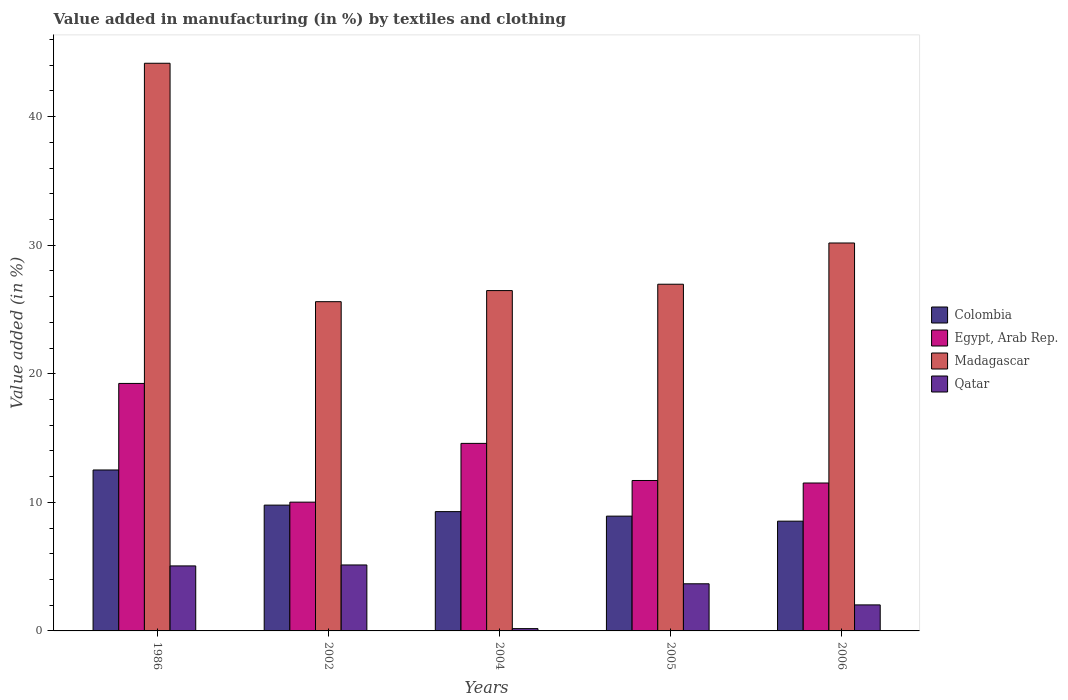How many groups of bars are there?
Provide a succinct answer. 5. Are the number of bars per tick equal to the number of legend labels?
Provide a short and direct response. Yes. Are the number of bars on each tick of the X-axis equal?
Your response must be concise. Yes. How many bars are there on the 1st tick from the left?
Your answer should be compact. 4. How many bars are there on the 5th tick from the right?
Your answer should be compact. 4. What is the label of the 3rd group of bars from the left?
Your answer should be very brief. 2004. In how many cases, is the number of bars for a given year not equal to the number of legend labels?
Your answer should be compact. 0. What is the percentage of value added in manufacturing by textiles and clothing in Colombia in 2002?
Your answer should be very brief. 9.78. Across all years, what is the maximum percentage of value added in manufacturing by textiles and clothing in Egypt, Arab Rep.?
Provide a succinct answer. 19.25. Across all years, what is the minimum percentage of value added in manufacturing by textiles and clothing in Egypt, Arab Rep.?
Give a very brief answer. 10.02. In which year was the percentage of value added in manufacturing by textiles and clothing in Egypt, Arab Rep. minimum?
Offer a very short reply. 2002. What is the total percentage of value added in manufacturing by textiles and clothing in Egypt, Arab Rep. in the graph?
Provide a succinct answer. 67.05. What is the difference between the percentage of value added in manufacturing by textiles and clothing in Egypt, Arab Rep. in 1986 and that in 2006?
Provide a succinct answer. 7.75. What is the difference between the percentage of value added in manufacturing by textiles and clothing in Colombia in 2005 and the percentage of value added in manufacturing by textiles and clothing in Egypt, Arab Rep. in 2006?
Ensure brevity in your answer.  -2.58. What is the average percentage of value added in manufacturing by textiles and clothing in Egypt, Arab Rep. per year?
Offer a very short reply. 13.41. In the year 1986, what is the difference between the percentage of value added in manufacturing by textiles and clothing in Colombia and percentage of value added in manufacturing by textiles and clothing in Madagascar?
Your answer should be compact. -31.63. What is the ratio of the percentage of value added in manufacturing by textiles and clothing in Qatar in 1986 to that in 2002?
Provide a short and direct response. 0.99. What is the difference between the highest and the second highest percentage of value added in manufacturing by textiles and clothing in Qatar?
Your answer should be very brief. 0.07. What is the difference between the highest and the lowest percentage of value added in manufacturing by textiles and clothing in Egypt, Arab Rep.?
Ensure brevity in your answer.  9.23. In how many years, is the percentage of value added in manufacturing by textiles and clothing in Egypt, Arab Rep. greater than the average percentage of value added in manufacturing by textiles and clothing in Egypt, Arab Rep. taken over all years?
Ensure brevity in your answer.  2. Is the sum of the percentage of value added in manufacturing by textiles and clothing in Qatar in 1986 and 2002 greater than the maximum percentage of value added in manufacturing by textiles and clothing in Egypt, Arab Rep. across all years?
Provide a succinct answer. No. What does the 3rd bar from the right in 2004 represents?
Give a very brief answer. Egypt, Arab Rep. How many bars are there?
Make the answer very short. 20. Are all the bars in the graph horizontal?
Your answer should be compact. No. Are the values on the major ticks of Y-axis written in scientific E-notation?
Give a very brief answer. No. Does the graph contain any zero values?
Keep it short and to the point. No. Does the graph contain grids?
Make the answer very short. No. Where does the legend appear in the graph?
Keep it short and to the point. Center right. How many legend labels are there?
Provide a short and direct response. 4. How are the legend labels stacked?
Your answer should be very brief. Vertical. What is the title of the graph?
Ensure brevity in your answer.  Value added in manufacturing (in %) by textiles and clothing. Does "St. Lucia" appear as one of the legend labels in the graph?
Make the answer very short. No. What is the label or title of the X-axis?
Your answer should be very brief. Years. What is the label or title of the Y-axis?
Offer a terse response. Value added (in %). What is the Value added (in %) in Colombia in 1986?
Your answer should be very brief. 12.52. What is the Value added (in %) in Egypt, Arab Rep. in 1986?
Ensure brevity in your answer.  19.25. What is the Value added (in %) of Madagascar in 1986?
Provide a short and direct response. 44.15. What is the Value added (in %) of Qatar in 1986?
Your response must be concise. 5.06. What is the Value added (in %) in Colombia in 2002?
Provide a short and direct response. 9.78. What is the Value added (in %) of Egypt, Arab Rep. in 2002?
Provide a succinct answer. 10.02. What is the Value added (in %) of Madagascar in 2002?
Ensure brevity in your answer.  25.61. What is the Value added (in %) in Qatar in 2002?
Your response must be concise. 5.13. What is the Value added (in %) in Colombia in 2004?
Give a very brief answer. 9.28. What is the Value added (in %) of Egypt, Arab Rep. in 2004?
Make the answer very short. 14.59. What is the Value added (in %) in Madagascar in 2004?
Ensure brevity in your answer.  26.47. What is the Value added (in %) of Qatar in 2004?
Make the answer very short. 0.18. What is the Value added (in %) of Colombia in 2005?
Make the answer very short. 8.93. What is the Value added (in %) of Egypt, Arab Rep. in 2005?
Your response must be concise. 11.7. What is the Value added (in %) in Madagascar in 2005?
Keep it short and to the point. 26.96. What is the Value added (in %) in Qatar in 2005?
Offer a terse response. 3.67. What is the Value added (in %) of Colombia in 2006?
Provide a short and direct response. 8.54. What is the Value added (in %) in Egypt, Arab Rep. in 2006?
Your answer should be very brief. 11.5. What is the Value added (in %) in Madagascar in 2006?
Make the answer very short. 30.17. What is the Value added (in %) of Qatar in 2006?
Provide a succinct answer. 2.02. Across all years, what is the maximum Value added (in %) of Colombia?
Offer a very short reply. 12.52. Across all years, what is the maximum Value added (in %) of Egypt, Arab Rep.?
Make the answer very short. 19.25. Across all years, what is the maximum Value added (in %) of Madagascar?
Ensure brevity in your answer.  44.15. Across all years, what is the maximum Value added (in %) of Qatar?
Your answer should be compact. 5.13. Across all years, what is the minimum Value added (in %) in Colombia?
Your response must be concise. 8.54. Across all years, what is the minimum Value added (in %) of Egypt, Arab Rep.?
Keep it short and to the point. 10.02. Across all years, what is the minimum Value added (in %) in Madagascar?
Ensure brevity in your answer.  25.61. Across all years, what is the minimum Value added (in %) in Qatar?
Ensure brevity in your answer.  0.18. What is the total Value added (in %) of Colombia in the graph?
Provide a succinct answer. 49.04. What is the total Value added (in %) in Egypt, Arab Rep. in the graph?
Provide a succinct answer. 67.05. What is the total Value added (in %) of Madagascar in the graph?
Keep it short and to the point. 153.36. What is the total Value added (in %) in Qatar in the graph?
Your answer should be very brief. 16.05. What is the difference between the Value added (in %) in Colombia in 1986 and that in 2002?
Make the answer very short. 2.73. What is the difference between the Value added (in %) in Egypt, Arab Rep. in 1986 and that in 2002?
Your answer should be compact. 9.23. What is the difference between the Value added (in %) in Madagascar in 1986 and that in 2002?
Provide a succinct answer. 18.54. What is the difference between the Value added (in %) in Qatar in 1986 and that in 2002?
Give a very brief answer. -0.07. What is the difference between the Value added (in %) of Colombia in 1986 and that in 2004?
Your answer should be compact. 3.24. What is the difference between the Value added (in %) in Egypt, Arab Rep. in 1986 and that in 2004?
Provide a short and direct response. 4.66. What is the difference between the Value added (in %) in Madagascar in 1986 and that in 2004?
Provide a succinct answer. 17.68. What is the difference between the Value added (in %) in Qatar in 1986 and that in 2004?
Make the answer very short. 4.88. What is the difference between the Value added (in %) in Colombia in 1986 and that in 2005?
Offer a terse response. 3.59. What is the difference between the Value added (in %) of Egypt, Arab Rep. in 1986 and that in 2005?
Offer a terse response. 7.55. What is the difference between the Value added (in %) in Madagascar in 1986 and that in 2005?
Your response must be concise. 17.19. What is the difference between the Value added (in %) in Qatar in 1986 and that in 2005?
Make the answer very short. 1.39. What is the difference between the Value added (in %) of Colombia in 1986 and that in 2006?
Ensure brevity in your answer.  3.98. What is the difference between the Value added (in %) of Egypt, Arab Rep. in 1986 and that in 2006?
Ensure brevity in your answer.  7.75. What is the difference between the Value added (in %) in Madagascar in 1986 and that in 2006?
Your answer should be very brief. 13.98. What is the difference between the Value added (in %) in Qatar in 1986 and that in 2006?
Offer a terse response. 3.03. What is the difference between the Value added (in %) of Colombia in 2002 and that in 2004?
Offer a very short reply. 0.5. What is the difference between the Value added (in %) of Egypt, Arab Rep. in 2002 and that in 2004?
Provide a succinct answer. -4.57. What is the difference between the Value added (in %) in Madagascar in 2002 and that in 2004?
Your answer should be compact. -0.86. What is the difference between the Value added (in %) of Qatar in 2002 and that in 2004?
Give a very brief answer. 4.95. What is the difference between the Value added (in %) in Colombia in 2002 and that in 2005?
Your response must be concise. 0.86. What is the difference between the Value added (in %) in Egypt, Arab Rep. in 2002 and that in 2005?
Make the answer very short. -1.68. What is the difference between the Value added (in %) in Madagascar in 2002 and that in 2005?
Your answer should be very brief. -1.36. What is the difference between the Value added (in %) in Qatar in 2002 and that in 2005?
Offer a terse response. 1.47. What is the difference between the Value added (in %) in Colombia in 2002 and that in 2006?
Provide a short and direct response. 1.25. What is the difference between the Value added (in %) in Egypt, Arab Rep. in 2002 and that in 2006?
Your answer should be very brief. -1.49. What is the difference between the Value added (in %) of Madagascar in 2002 and that in 2006?
Provide a succinct answer. -4.57. What is the difference between the Value added (in %) of Qatar in 2002 and that in 2006?
Your response must be concise. 3.11. What is the difference between the Value added (in %) in Colombia in 2004 and that in 2005?
Make the answer very short. 0.35. What is the difference between the Value added (in %) in Egypt, Arab Rep. in 2004 and that in 2005?
Your response must be concise. 2.89. What is the difference between the Value added (in %) in Madagascar in 2004 and that in 2005?
Your response must be concise. -0.49. What is the difference between the Value added (in %) in Qatar in 2004 and that in 2005?
Offer a terse response. -3.49. What is the difference between the Value added (in %) in Colombia in 2004 and that in 2006?
Keep it short and to the point. 0.74. What is the difference between the Value added (in %) in Egypt, Arab Rep. in 2004 and that in 2006?
Keep it short and to the point. 3.08. What is the difference between the Value added (in %) of Madagascar in 2004 and that in 2006?
Ensure brevity in your answer.  -3.7. What is the difference between the Value added (in %) of Qatar in 2004 and that in 2006?
Keep it short and to the point. -1.85. What is the difference between the Value added (in %) in Colombia in 2005 and that in 2006?
Offer a terse response. 0.39. What is the difference between the Value added (in %) of Egypt, Arab Rep. in 2005 and that in 2006?
Your response must be concise. 0.2. What is the difference between the Value added (in %) in Madagascar in 2005 and that in 2006?
Offer a very short reply. -3.21. What is the difference between the Value added (in %) in Qatar in 2005 and that in 2006?
Your response must be concise. 1.64. What is the difference between the Value added (in %) of Colombia in 1986 and the Value added (in %) of Egypt, Arab Rep. in 2002?
Provide a short and direct response. 2.5. What is the difference between the Value added (in %) in Colombia in 1986 and the Value added (in %) in Madagascar in 2002?
Offer a terse response. -13.09. What is the difference between the Value added (in %) of Colombia in 1986 and the Value added (in %) of Qatar in 2002?
Make the answer very short. 7.39. What is the difference between the Value added (in %) of Egypt, Arab Rep. in 1986 and the Value added (in %) of Madagascar in 2002?
Make the answer very short. -6.36. What is the difference between the Value added (in %) of Egypt, Arab Rep. in 1986 and the Value added (in %) of Qatar in 2002?
Ensure brevity in your answer.  14.12. What is the difference between the Value added (in %) of Madagascar in 1986 and the Value added (in %) of Qatar in 2002?
Offer a terse response. 39.02. What is the difference between the Value added (in %) in Colombia in 1986 and the Value added (in %) in Egypt, Arab Rep. in 2004?
Make the answer very short. -2.07. What is the difference between the Value added (in %) of Colombia in 1986 and the Value added (in %) of Madagascar in 2004?
Provide a short and direct response. -13.95. What is the difference between the Value added (in %) in Colombia in 1986 and the Value added (in %) in Qatar in 2004?
Keep it short and to the point. 12.34. What is the difference between the Value added (in %) of Egypt, Arab Rep. in 1986 and the Value added (in %) of Madagascar in 2004?
Offer a terse response. -7.22. What is the difference between the Value added (in %) of Egypt, Arab Rep. in 1986 and the Value added (in %) of Qatar in 2004?
Your response must be concise. 19.07. What is the difference between the Value added (in %) in Madagascar in 1986 and the Value added (in %) in Qatar in 2004?
Your answer should be very brief. 43.97. What is the difference between the Value added (in %) of Colombia in 1986 and the Value added (in %) of Egypt, Arab Rep. in 2005?
Keep it short and to the point. 0.82. What is the difference between the Value added (in %) of Colombia in 1986 and the Value added (in %) of Madagascar in 2005?
Provide a succinct answer. -14.45. What is the difference between the Value added (in %) in Colombia in 1986 and the Value added (in %) in Qatar in 2005?
Your answer should be very brief. 8.85. What is the difference between the Value added (in %) in Egypt, Arab Rep. in 1986 and the Value added (in %) in Madagascar in 2005?
Your answer should be very brief. -7.71. What is the difference between the Value added (in %) of Egypt, Arab Rep. in 1986 and the Value added (in %) of Qatar in 2005?
Provide a short and direct response. 15.58. What is the difference between the Value added (in %) in Madagascar in 1986 and the Value added (in %) in Qatar in 2005?
Ensure brevity in your answer.  40.48. What is the difference between the Value added (in %) in Colombia in 1986 and the Value added (in %) in Egypt, Arab Rep. in 2006?
Offer a terse response. 1.01. What is the difference between the Value added (in %) in Colombia in 1986 and the Value added (in %) in Madagascar in 2006?
Provide a short and direct response. -17.65. What is the difference between the Value added (in %) of Colombia in 1986 and the Value added (in %) of Qatar in 2006?
Your answer should be compact. 10.49. What is the difference between the Value added (in %) in Egypt, Arab Rep. in 1986 and the Value added (in %) in Madagascar in 2006?
Your answer should be compact. -10.92. What is the difference between the Value added (in %) of Egypt, Arab Rep. in 1986 and the Value added (in %) of Qatar in 2006?
Offer a very short reply. 17.22. What is the difference between the Value added (in %) of Madagascar in 1986 and the Value added (in %) of Qatar in 2006?
Make the answer very short. 42.12. What is the difference between the Value added (in %) in Colombia in 2002 and the Value added (in %) in Egypt, Arab Rep. in 2004?
Offer a terse response. -4.8. What is the difference between the Value added (in %) of Colombia in 2002 and the Value added (in %) of Madagascar in 2004?
Your response must be concise. -16.69. What is the difference between the Value added (in %) in Colombia in 2002 and the Value added (in %) in Qatar in 2004?
Make the answer very short. 9.61. What is the difference between the Value added (in %) in Egypt, Arab Rep. in 2002 and the Value added (in %) in Madagascar in 2004?
Your answer should be compact. -16.45. What is the difference between the Value added (in %) of Egypt, Arab Rep. in 2002 and the Value added (in %) of Qatar in 2004?
Keep it short and to the point. 9.84. What is the difference between the Value added (in %) in Madagascar in 2002 and the Value added (in %) in Qatar in 2004?
Offer a terse response. 25.43. What is the difference between the Value added (in %) in Colombia in 2002 and the Value added (in %) in Egypt, Arab Rep. in 2005?
Give a very brief answer. -1.92. What is the difference between the Value added (in %) in Colombia in 2002 and the Value added (in %) in Madagascar in 2005?
Your answer should be compact. -17.18. What is the difference between the Value added (in %) in Colombia in 2002 and the Value added (in %) in Qatar in 2005?
Your response must be concise. 6.12. What is the difference between the Value added (in %) in Egypt, Arab Rep. in 2002 and the Value added (in %) in Madagascar in 2005?
Give a very brief answer. -16.95. What is the difference between the Value added (in %) of Egypt, Arab Rep. in 2002 and the Value added (in %) of Qatar in 2005?
Provide a short and direct response. 6.35. What is the difference between the Value added (in %) in Madagascar in 2002 and the Value added (in %) in Qatar in 2005?
Provide a succinct answer. 21.94. What is the difference between the Value added (in %) in Colombia in 2002 and the Value added (in %) in Egypt, Arab Rep. in 2006?
Your answer should be compact. -1.72. What is the difference between the Value added (in %) in Colombia in 2002 and the Value added (in %) in Madagascar in 2006?
Offer a very short reply. -20.39. What is the difference between the Value added (in %) in Colombia in 2002 and the Value added (in %) in Qatar in 2006?
Make the answer very short. 7.76. What is the difference between the Value added (in %) in Egypt, Arab Rep. in 2002 and the Value added (in %) in Madagascar in 2006?
Keep it short and to the point. -20.16. What is the difference between the Value added (in %) in Egypt, Arab Rep. in 2002 and the Value added (in %) in Qatar in 2006?
Your answer should be very brief. 7.99. What is the difference between the Value added (in %) in Madagascar in 2002 and the Value added (in %) in Qatar in 2006?
Keep it short and to the point. 23.58. What is the difference between the Value added (in %) of Colombia in 2004 and the Value added (in %) of Egypt, Arab Rep. in 2005?
Your answer should be compact. -2.42. What is the difference between the Value added (in %) of Colombia in 2004 and the Value added (in %) of Madagascar in 2005?
Give a very brief answer. -17.68. What is the difference between the Value added (in %) in Colombia in 2004 and the Value added (in %) in Qatar in 2005?
Provide a short and direct response. 5.61. What is the difference between the Value added (in %) in Egypt, Arab Rep. in 2004 and the Value added (in %) in Madagascar in 2005?
Your answer should be compact. -12.38. What is the difference between the Value added (in %) of Egypt, Arab Rep. in 2004 and the Value added (in %) of Qatar in 2005?
Make the answer very short. 10.92. What is the difference between the Value added (in %) in Madagascar in 2004 and the Value added (in %) in Qatar in 2005?
Give a very brief answer. 22.8. What is the difference between the Value added (in %) in Colombia in 2004 and the Value added (in %) in Egypt, Arab Rep. in 2006?
Keep it short and to the point. -2.22. What is the difference between the Value added (in %) in Colombia in 2004 and the Value added (in %) in Madagascar in 2006?
Give a very brief answer. -20.89. What is the difference between the Value added (in %) in Colombia in 2004 and the Value added (in %) in Qatar in 2006?
Provide a short and direct response. 7.26. What is the difference between the Value added (in %) of Egypt, Arab Rep. in 2004 and the Value added (in %) of Madagascar in 2006?
Offer a terse response. -15.59. What is the difference between the Value added (in %) of Egypt, Arab Rep. in 2004 and the Value added (in %) of Qatar in 2006?
Offer a very short reply. 12.56. What is the difference between the Value added (in %) of Madagascar in 2004 and the Value added (in %) of Qatar in 2006?
Give a very brief answer. 24.45. What is the difference between the Value added (in %) in Colombia in 2005 and the Value added (in %) in Egypt, Arab Rep. in 2006?
Your answer should be very brief. -2.58. What is the difference between the Value added (in %) of Colombia in 2005 and the Value added (in %) of Madagascar in 2006?
Your response must be concise. -21.24. What is the difference between the Value added (in %) in Colombia in 2005 and the Value added (in %) in Qatar in 2006?
Ensure brevity in your answer.  6.9. What is the difference between the Value added (in %) in Egypt, Arab Rep. in 2005 and the Value added (in %) in Madagascar in 2006?
Your answer should be very brief. -18.47. What is the difference between the Value added (in %) in Egypt, Arab Rep. in 2005 and the Value added (in %) in Qatar in 2006?
Your response must be concise. 9.68. What is the difference between the Value added (in %) of Madagascar in 2005 and the Value added (in %) of Qatar in 2006?
Keep it short and to the point. 24.94. What is the average Value added (in %) in Colombia per year?
Provide a short and direct response. 9.81. What is the average Value added (in %) of Egypt, Arab Rep. per year?
Keep it short and to the point. 13.41. What is the average Value added (in %) in Madagascar per year?
Your answer should be very brief. 30.67. What is the average Value added (in %) of Qatar per year?
Provide a succinct answer. 3.21. In the year 1986, what is the difference between the Value added (in %) of Colombia and Value added (in %) of Egypt, Arab Rep.?
Your answer should be compact. -6.73. In the year 1986, what is the difference between the Value added (in %) in Colombia and Value added (in %) in Madagascar?
Provide a short and direct response. -31.63. In the year 1986, what is the difference between the Value added (in %) in Colombia and Value added (in %) in Qatar?
Give a very brief answer. 7.46. In the year 1986, what is the difference between the Value added (in %) of Egypt, Arab Rep. and Value added (in %) of Madagascar?
Offer a terse response. -24.9. In the year 1986, what is the difference between the Value added (in %) in Egypt, Arab Rep. and Value added (in %) in Qatar?
Give a very brief answer. 14.19. In the year 1986, what is the difference between the Value added (in %) in Madagascar and Value added (in %) in Qatar?
Offer a terse response. 39.09. In the year 2002, what is the difference between the Value added (in %) of Colombia and Value added (in %) of Egypt, Arab Rep.?
Provide a short and direct response. -0.23. In the year 2002, what is the difference between the Value added (in %) of Colombia and Value added (in %) of Madagascar?
Provide a short and direct response. -15.82. In the year 2002, what is the difference between the Value added (in %) of Colombia and Value added (in %) of Qatar?
Ensure brevity in your answer.  4.65. In the year 2002, what is the difference between the Value added (in %) of Egypt, Arab Rep. and Value added (in %) of Madagascar?
Keep it short and to the point. -15.59. In the year 2002, what is the difference between the Value added (in %) of Egypt, Arab Rep. and Value added (in %) of Qatar?
Make the answer very short. 4.88. In the year 2002, what is the difference between the Value added (in %) in Madagascar and Value added (in %) in Qatar?
Your response must be concise. 20.48. In the year 2004, what is the difference between the Value added (in %) of Colombia and Value added (in %) of Egypt, Arab Rep.?
Provide a short and direct response. -5.31. In the year 2004, what is the difference between the Value added (in %) in Colombia and Value added (in %) in Madagascar?
Provide a succinct answer. -17.19. In the year 2004, what is the difference between the Value added (in %) of Colombia and Value added (in %) of Qatar?
Your answer should be compact. 9.1. In the year 2004, what is the difference between the Value added (in %) of Egypt, Arab Rep. and Value added (in %) of Madagascar?
Your answer should be very brief. -11.88. In the year 2004, what is the difference between the Value added (in %) in Egypt, Arab Rep. and Value added (in %) in Qatar?
Your response must be concise. 14.41. In the year 2004, what is the difference between the Value added (in %) in Madagascar and Value added (in %) in Qatar?
Ensure brevity in your answer.  26.29. In the year 2005, what is the difference between the Value added (in %) in Colombia and Value added (in %) in Egypt, Arab Rep.?
Provide a succinct answer. -2.77. In the year 2005, what is the difference between the Value added (in %) in Colombia and Value added (in %) in Madagascar?
Offer a very short reply. -18.04. In the year 2005, what is the difference between the Value added (in %) of Colombia and Value added (in %) of Qatar?
Make the answer very short. 5.26. In the year 2005, what is the difference between the Value added (in %) in Egypt, Arab Rep. and Value added (in %) in Madagascar?
Provide a succinct answer. -15.26. In the year 2005, what is the difference between the Value added (in %) of Egypt, Arab Rep. and Value added (in %) of Qatar?
Your answer should be very brief. 8.03. In the year 2005, what is the difference between the Value added (in %) in Madagascar and Value added (in %) in Qatar?
Your answer should be very brief. 23.3. In the year 2006, what is the difference between the Value added (in %) in Colombia and Value added (in %) in Egypt, Arab Rep.?
Give a very brief answer. -2.97. In the year 2006, what is the difference between the Value added (in %) in Colombia and Value added (in %) in Madagascar?
Your answer should be compact. -21.63. In the year 2006, what is the difference between the Value added (in %) of Colombia and Value added (in %) of Qatar?
Your response must be concise. 6.51. In the year 2006, what is the difference between the Value added (in %) of Egypt, Arab Rep. and Value added (in %) of Madagascar?
Make the answer very short. -18.67. In the year 2006, what is the difference between the Value added (in %) of Egypt, Arab Rep. and Value added (in %) of Qatar?
Provide a succinct answer. 9.48. In the year 2006, what is the difference between the Value added (in %) of Madagascar and Value added (in %) of Qatar?
Your answer should be compact. 28.15. What is the ratio of the Value added (in %) of Colombia in 1986 to that in 2002?
Ensure brevity in your answer.  1.28. What is the ratio of the Value added (in %) in Egypt, Arab Rep. in 1986 to that in 2002?
Ensure brevity in your answer.  1.92. What is the ratio of the Value added (in %) in Madagascar in 1986 to that in 2002?
Keep it short and to the point. 1.72. What is the ratio of the Value added (in %) in Qatar in 1986 to that in 2002?
Offer a terse response. 0.99. What is the ratio of the Value added (in %) in Colombia in 1986 to that in 2004?
Offer a terse response. 1.35. What is the ratio of the Value added (in %) of Egypt, Arab Rep. in 1986 to that in 2004?
Provide a short and direct response. 1.32. What is the ratio of the Value added (in %) in Madagascar in 1986 to that in 2004?
Ensure brevity in your answer.  1.67. What is the ratio of the Value added (in %) in Qatar in 1986 to that in 2004?
Keep it short and to the point. 28.3. What is the ratio of the Value added (in %) in Colombia in 1986 to that in 2005?
Offer a very short reply. 1.4. What is the ratio of the Value added (in %) in Egypt, Arab Rep. in 1986 to that in 2005?
Give a very brief answer. 1.65. What is the ratio of the Value added (in %) of Madagascar in 1986 to that in 2005?
Provide a succinct answer. 1.64. What is the ratio of the Value added (in %) of Qatar in 1986 to that in 2005?
Your response must be concise. 1.38. What is the ratio of the Value added (in %) of Colombia in 1986 to that in 2006?
Your answer should be very brief. 1.47. What is the ratio of the Value added (in %) in Egypt, Arab Rep. in 1986 to that in 2006?
Offer a very short reply. 1.67. What is the ratio of the Value added (in %) of Madagascar in 1986 to that in 2006?
Offer a terse response. 1.46. What is the ratio of the Value added (in %) in Qatar in 1986 to that in 2006?
Keep it short and to the point. 2.5. What is the ratio of the Value added (in %) in Colombia in 2002 to that in 2004?
Provide a short and direct response. 1.05. What is the ratio of the Value added (in %) of Egypt, Arab Rep. in 2002 to that in 2004?
Your answer should be very brief. 0.69. What is the ratio of the Value added (in %) in Madagascar in 2002 to that in 2004?
Ensure brevity in your answer.  0.97. What is the ratio of the Value added (in %) of Qatar in 2002 to that in 2004?
Your answer should be compact. 28.72. What is the ratio of the Value added (in %) in Colombia in 2002 to that in 2005?
Give a very brief answer. 1.1. What is the ratio of the Value added (in %) in Egypt, Arab Rep. in 2002 to that in 2005?
Your response must be concise. 0.86. What is the ratio of the Value added (in %) of Madagascar in 2002 to that in 2005?
Your response must be concise. 0.95. What is the ratio of the Value added (in %) of Qatar in 2002 to that in 2005?
Offer a very short reply. 1.4. What is the ratio of the Value added (in %) of Colombia in 2002 to that in 2006?
Your answer should be compact. 1.15. What is the ratio of the Value added (in %) in Egypt, Arab Rep. in 2002 to that in 2006?
Your answer should be compact. 0.87. What is the ratio of the Value added (in %) in Madagascar in 2002 to that in 2006?
Provide a short and direct response. 0.85. What is the ratio of the Value added (in %) of Qatar in 2002 to that in 2006?
Offer a terse response. 2.53. What is the ratio of the Value added (in %) in Colombia in 2004 to that in 2005?
Make the answer very short. 1.04. What is the ratio of the Value added (in %) of Egypt, Arab Rep. in 2004 to that in 2005?
Ensure brevity in your answer.  1.25. What is the ratio of the Value added (in %) in Madagascar in 2004 to that in 2005?
Ensure brevity in your answer.  0.98. What is the ratio of the Value added (in %) in Qatar in 2004 to that in 2005?
Ensure brevity in your answer.  0.05. What is the ratio of the Value added (in %) in Colombia in 2004 to that in 2006?
Provide a succinct answer. 1.09. What is the ratio of the Value added (in %) of Egypt, Arab Rep. in 2004 to that in 2006?
Make the answer very short. 1.27. What is the ratio of the Value added (in %) of Madagascar in 2004 to that in 2006?
Ensure brevity in your answer.  0.88. What is the ratio of the Value added (in %) of Qatar in 2004 to that in 2006?
Give a very brief answer. 0.09. What is the ratio of the Value added (in %) in Colombia in 2005 to that in 2006?
Make the answer very short. 1.05. What is the ratio of the Value added (in %) of Egypt, Arab Rep. in 2005 to that in 2006?
Provide a short and direct response. 1.02. What is the ratio of the Value added (in %) in Madagascar in 2005 to that in 2006?
Your answer should be compact. 0.89. What is the ratio of the Value added (in %) of Qatar in 2005 to that in 2006?
Your answer should be compact. 1.81. What is the difference between the highest and the second highest Value added (in %) of Colombia?
Make the answer very short. 2.73. What is the difference between the highest and the second highest Value added (in %) in Egypt, Arab Rep.?
Provide a short and direct response. 4.66. What is the difference between the highest and the second highest Value added (in %) of Madagascar?
Offer a terse response. 13.98. What is the difference between the highest and the second highest Value added (in %) in Qatar?
Offer a terse response. 0.07. What is the difference between the highest and the lowest Value added (in %) in Colombia?
Keep it short and to the point. 3.98. What is the difference between the highest and the lowest Value added (in %) in Egypt, Arab Rep.?
Ensure brevity in your answer.  9.23. What is the difference between the highest and the lowest Value added (in %) of Madagascar?
Keep it short and to the point. 18.54. What is the difference between the highest and the lowest Value added (in %) in Qatar?
Ensure brevity in your answer.  4.95. 